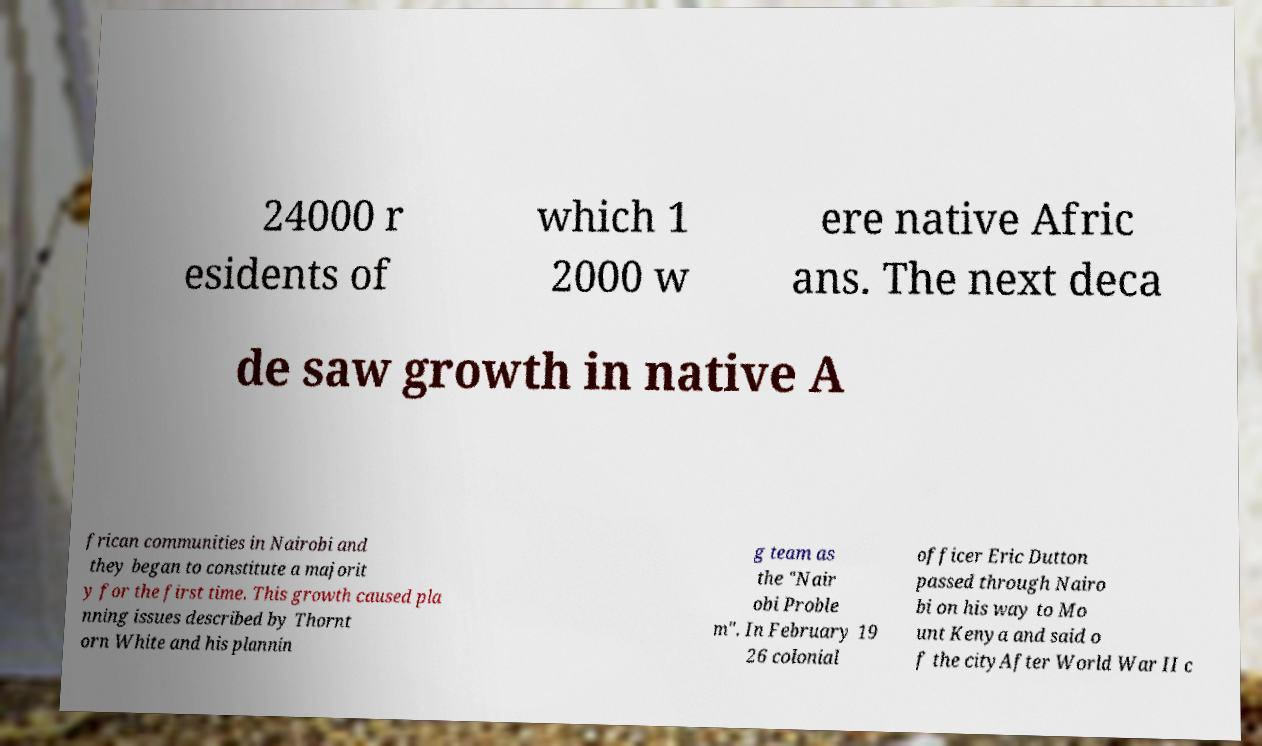What messages or text are displayed in this image? I need them in a readable, typed format. 24000 r esidents of which 1 2000 w ere native Afric ans. The next deca de saw growth in native A frican communities in Nairobi and they began to constitute a majorit y for the first time. This growth caused pla nning issues described by Thornt orn White and his plannin g team as the "Nair obi Proble m". In February 19 26 colonial officer Eric Dutton passed through Nairo bi on his way to Mo unt Kenya and said o f the cityAfter World War II c 